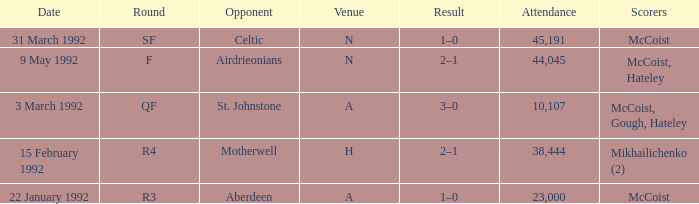What is the result with an attendance larger than 10,107 and Celtic as the opponent? 1–0. 